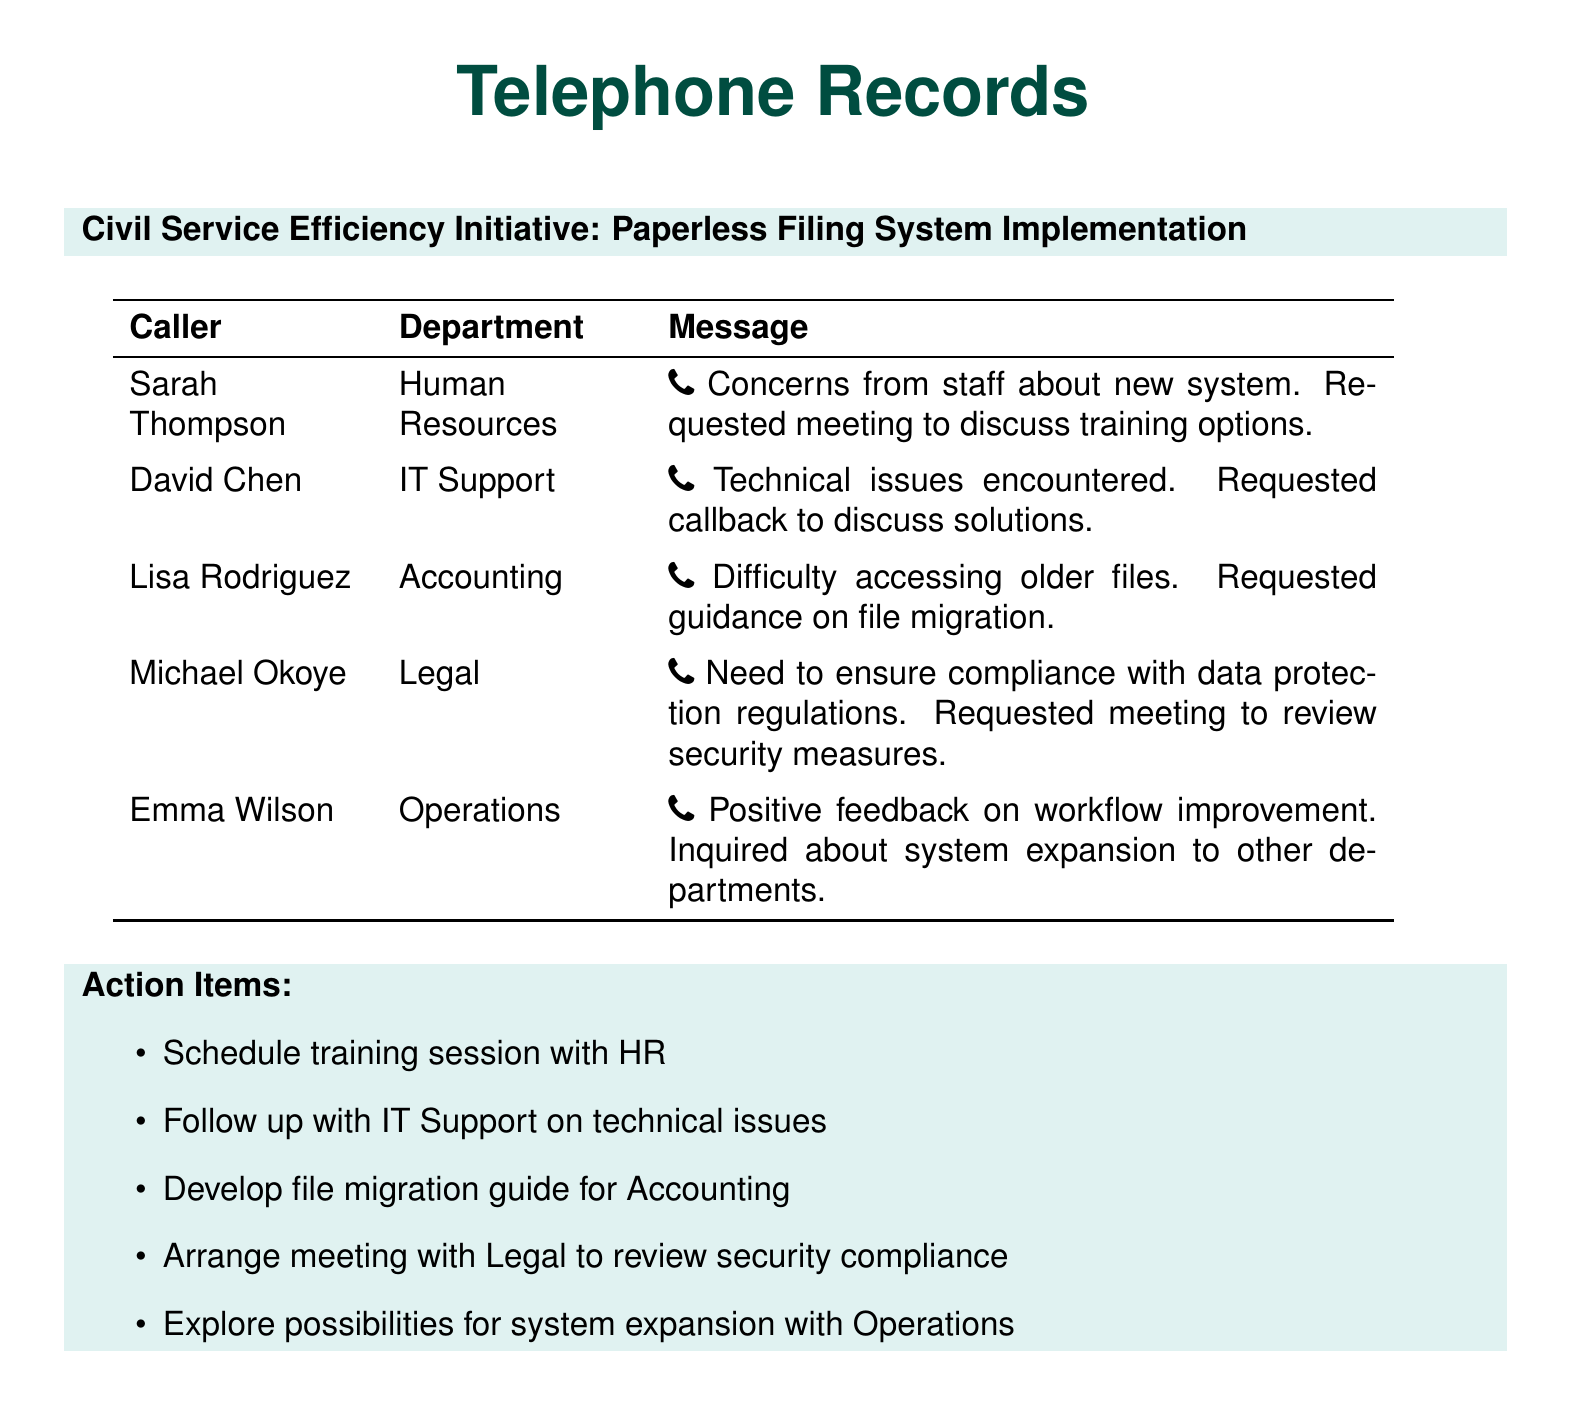What is the name of the caller from Human Resources? The name of the caller from Human Resources is mentioned in the document as Sarah Thompson.
Answer: Sarah Thompson What department did David Chen belong to? The document states that David Chen is from the IT Support department.
Answer: IT Support How many action items are listed in the document? The document provides a list of five action items, one for each department discussed.
Answer: 5 What positive feedback did Emma Wilson provide? Emma Wilson mentioned positive feedback regarding workflow improvement due to the new system implementation.
Answer: Workflow improvement What issue did Lisa Rodriguez report about? Lisa Rodriguez encountered difficulty in accessing older files as part of the transition to the new system.
Answer: Difficulty accessing older files Who requested a meeting to discuss training options? The individual who requested a meeting to discuss training options is from Human Resources, specifically Sarah Thompson.
Answer: Sarah Thompson Which department's feedback inquired about the system's expansion? The inquiry about system expansion came from the Operations department, as noted in Emma Wilson's message.
Answer: Operations What was the main concern of Michael Okoye? Michael Okoye's main concern was ensuring compliance with data protection regulations.
Answer: Compliance with data protection regulations What type of document is presented here? The document is a collection of telephone records related to the implementation of a new filing system.
Answer: Telephone records 